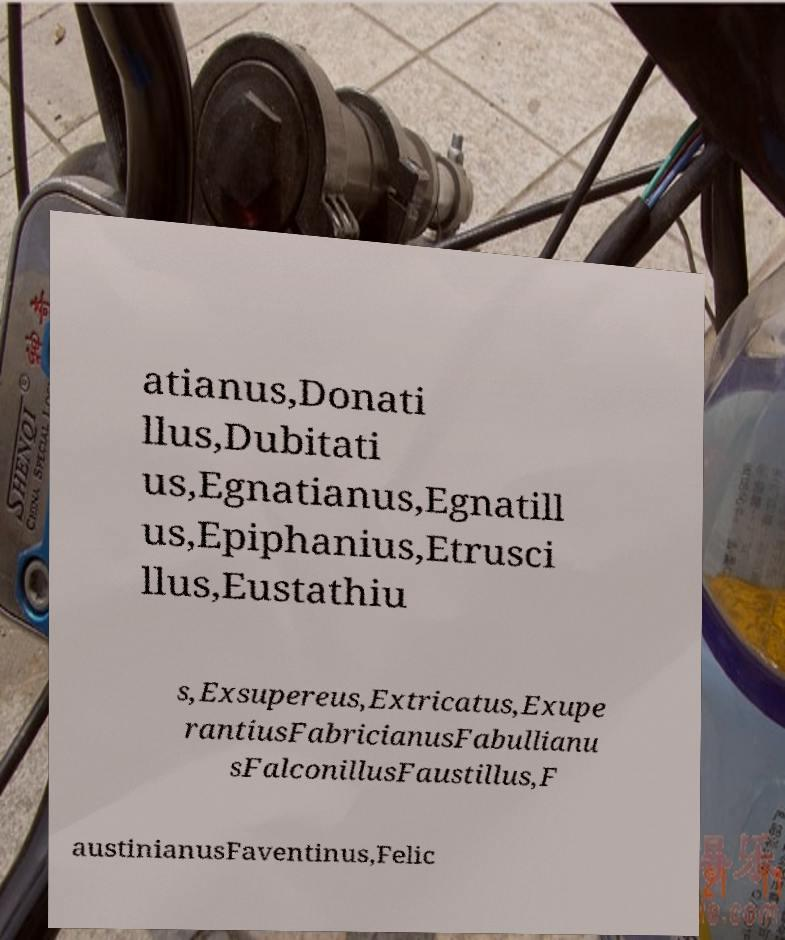Could you extract and type out the text from this image? atianus,Donati llus,Dubitati us,Egnatianus,Egnatill us,Epiphanius,Etrusci llus,Eustathiu s,Exsupereus,Extricatus,Exupe rantiusFabricianusFabullianu sFalconillusFaustillus,F austinianusFaventinus,Felic 